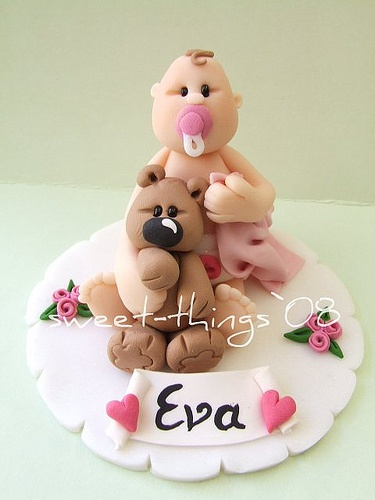Describe the objects in this image and their specific colors. I can see cake in beige, white, tan, and brown tones and teddy bear in beige, gray, tan, and maroon tones in this image. 